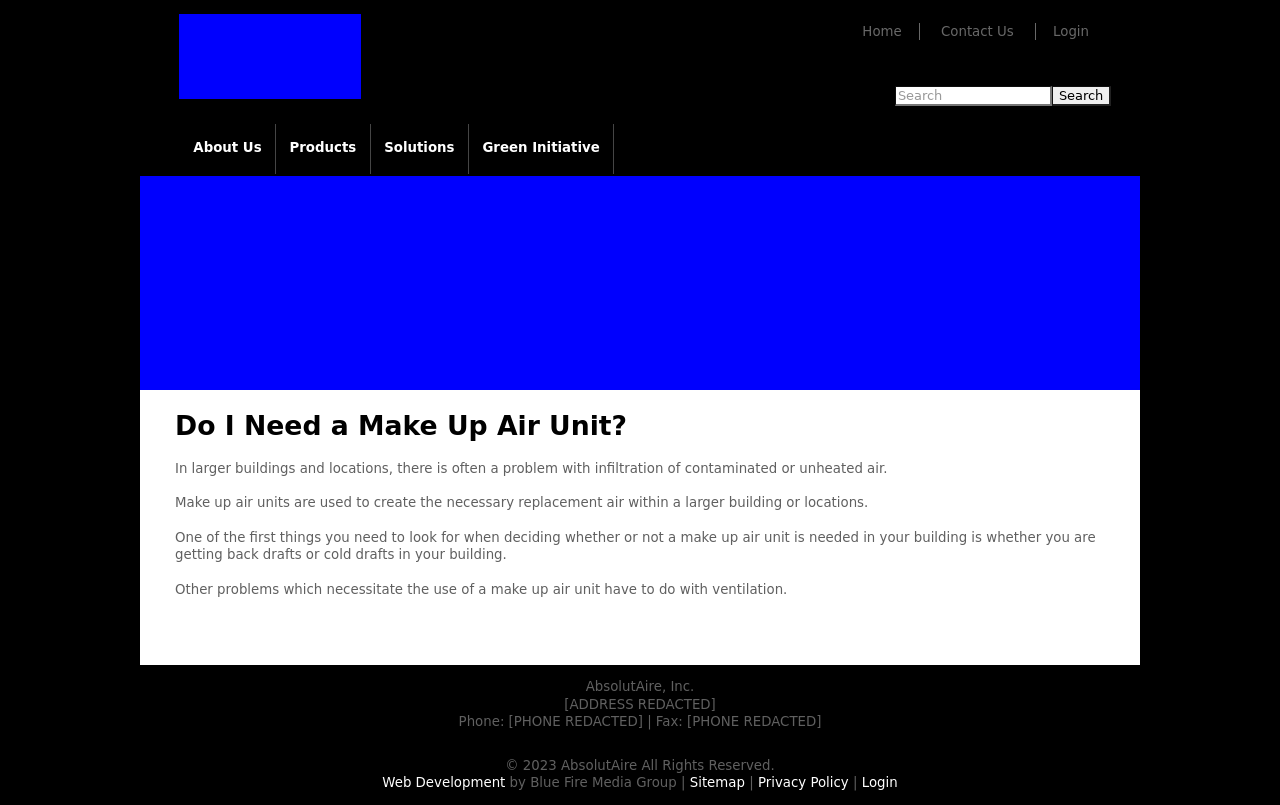What are the usability considerations taken into account in the layout of this website? This website layout includes a clear, easy-to-navigate top menu which enhances user experience by allowing for quick, intuitive navigation to various sections like 'Products,' 'Solutions,' and 'Green Initiative.' The search bar is prominently placed, facilitating easy access. The layout focuses on minimal scrolling with important information, like contact details and login options, directly visible. The page avoids clutter, which enhances usability by not overwhelming the user with too much information at once. 